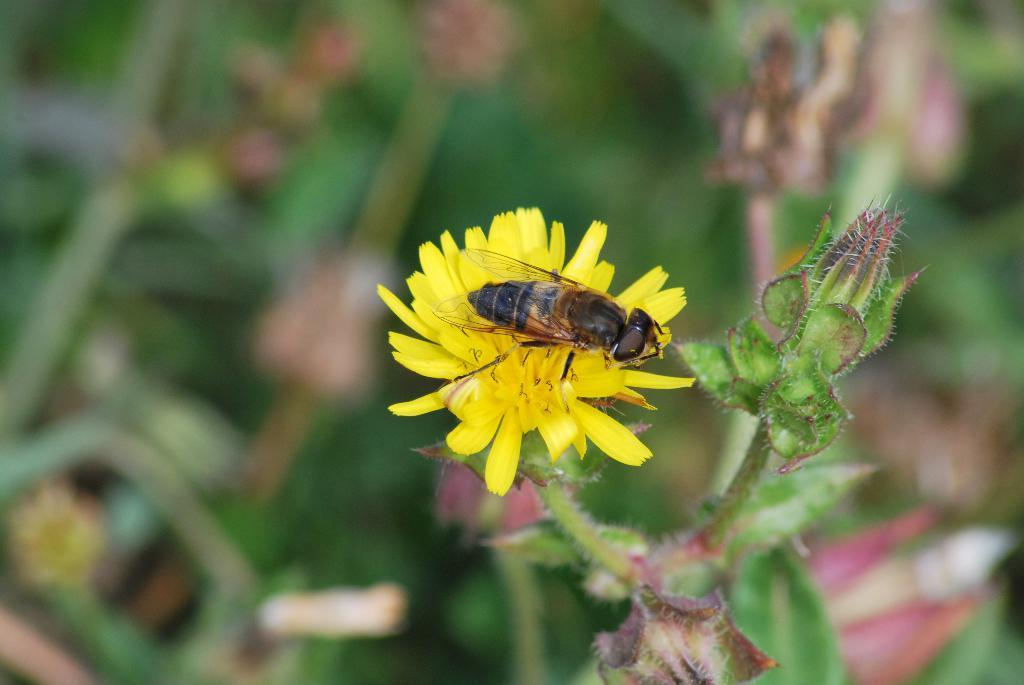What type of insect is in the image? There is a honey bee in the image. What is the honey bee doing in the image? The honey bee is on a yellow flower. What is the flower part of in the image? The flower is part of a plant. How would you describe the background of the image? The background of the image is blurred. What songs can be heard playing in the background of the image? There are no songs or sounds present in the image, as it is a still photograph. 